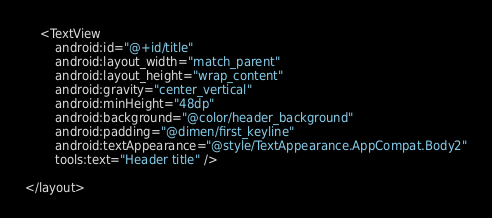<code> <loc_0><loc_0><loc_500><loc_500><_XML_>
    <TextView
        android:id="@+id/title"
        android:layout_width="match_parent"
        android:layout_height="wrap_content"
        android:gravity="center_vertical"
        android:minHeight="48dp"
        android:background="@color/header_background"
        android:padding="@dimen/first_keyline"
        android:textAppearance="@style/TextAppearance.AppCompat.Body2"
        tools:text="Header title" />

</layout></code> 